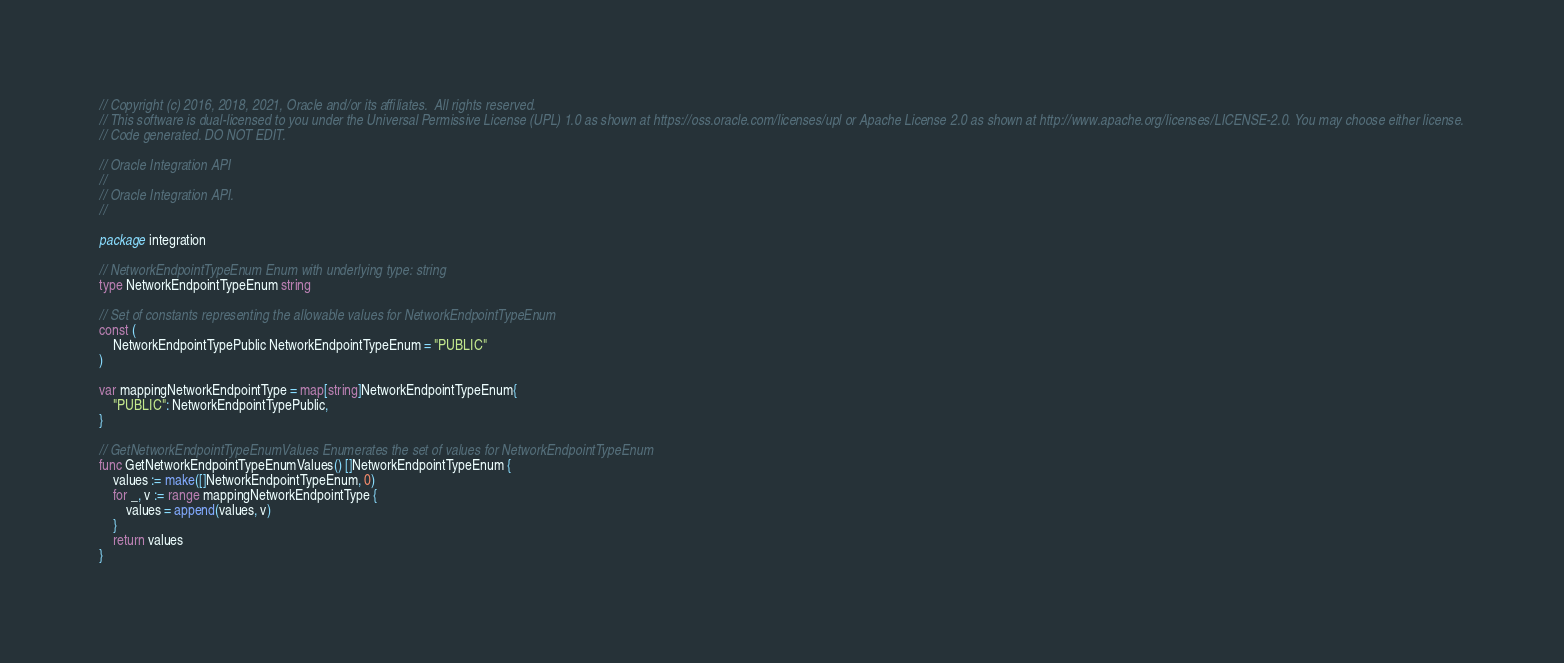Convert code to text. <code><loc_0><loc_0><loc_500><loc_500><_Go_>// Copyright (c) 2016, 2018, 2021, Oracle and/or its affiliates.  All rights reserved.
// This software is dual-licensed to you under the Universal Permissive License (UPL) 1.0 as shown at https://oss.oracle.com/licenses/upl or Apache License 2.0 as shown at http://www.apache.org/licenses/LICENSE-2.0. You may choose either license.
// Code generated. DO NOT EDIT.

// Oracle Integration API
//
// Oracle Integration API.
//

package integration

// NetworkEndpointTypeEnum Enum with underlying type: string
type NetworkEndpointTypeEnum string

// Set of constants representing the allowable values for NetworkEndpointTypeEnum
const (
	NetworkEndpointTypePublic NetworkEndpointTypeEnum = "PUBLIC"
)

var mappingNetworkEndpointType = map[string]NetworkEndpointTypeEnum{
	"PUBLIC": NetworkEndpointTypePublic,
}

// GetNetworkEndpointTypeEnumValues Enumerates the set of values for NetworkEndpointTypeEnum
func GetNetworkEndpointTypeEnumValues() []NetworkEndpointTypeEnum {
	values := make([]NetworkEndpointTypeEnum, 0)
	for _, v := range mappingNetworkEndpointType {
		values = append(values, v)
	}
	return values
}
</code> 